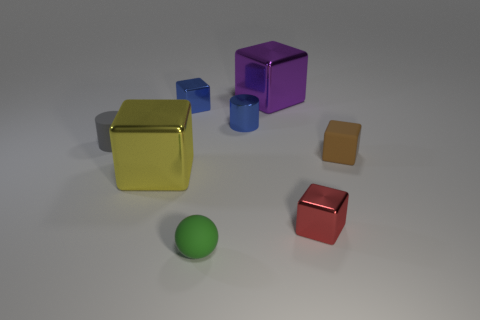The object that is the same color as the small metal cylinder is what shape?
Keep it short and to the point. Cube. Is there a large blue thing of the same shape as the purple thing?
Ensure brevity in your answer.  No. There is a red metallic thing that is the same size as the brown object; what shape is it?
Offer a terse response. Cube. How many cubes are both behind the small gray thing and to the left of the tiny green object?
Keep it short and to the point. 1. Is the number of tiny green things right of the blue metal cylinder less than the number of tiny yellow metal blocks?
Ensure brevity in your answer.  No. Are there any gray matte blocks of the same size as the yellow metallic object?
Offer a terse response. No. There is another large cube that is the same material as the purple cube; what color is it?
Make the answer very short. Yellow. There is a large metallic block that is on the right side of the tiny green sphere; how many spheres are in front of it?
Your answer should be very brief. 1. The small thing that is on the left side of the big purple block and in front of the gray object is made of what material?
Provide a short and direct response. Rubber. Do the tiny metal thing that is in front of the tiny rubber cube and the purple object have the same shape?
Your answer should be very brief. Yes. 